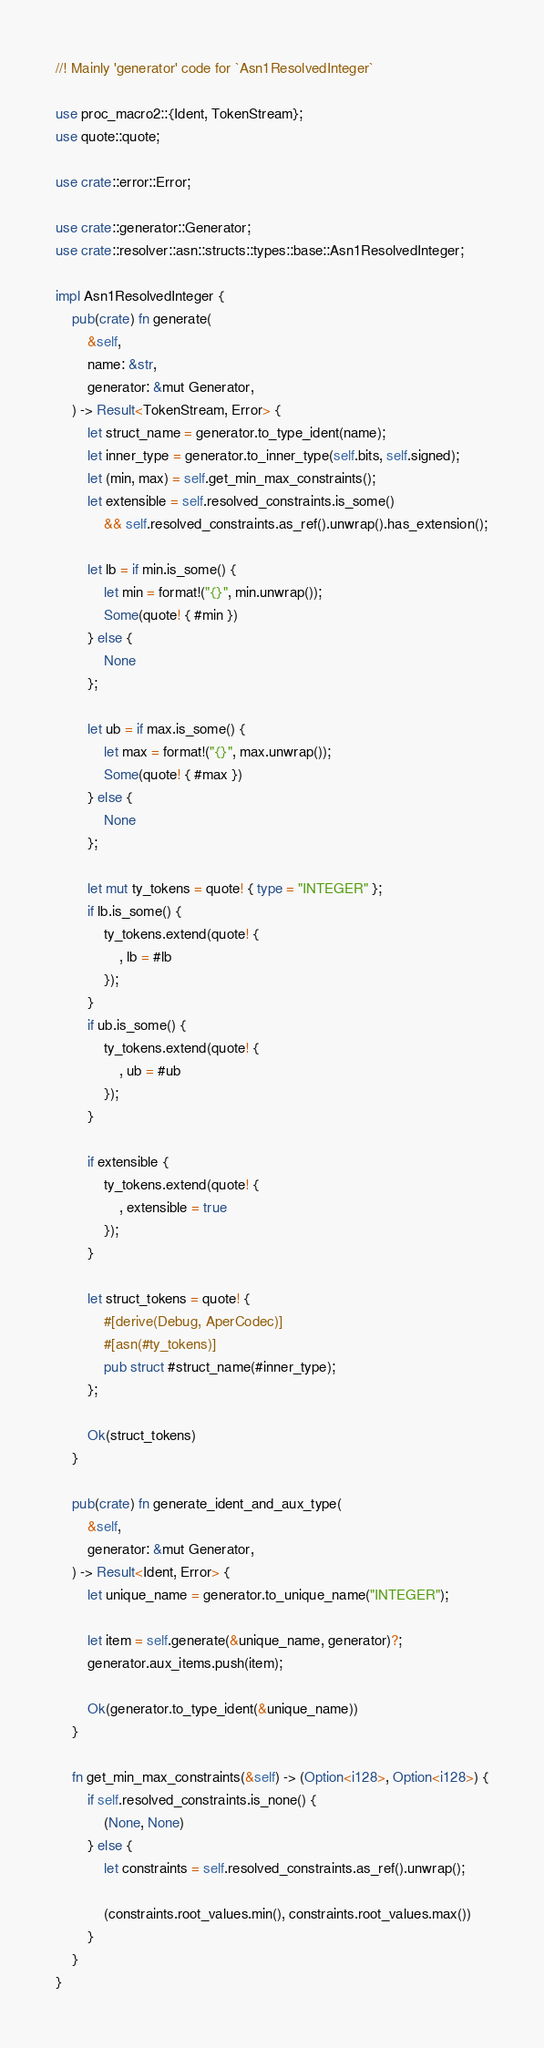<code> <loc_0><loc_0><loc_500><loc_500><_Rust_>//! Mainly 'generator' code for `Asn1ResolvedInteger`

use proc_macro2::{Ident, TokenStream};
use quote::quote;

use crate::error::Error;

use crate::generator::Generator;
use crate::resolver::asn::structs::types::base::Asn1ResolvedInteger;

impl Asn1ResolvedInteger {
    pub(crate) fn generate(
        &self,
        name: &str,
        generator: &mut Generator,
    ) -> Result<TokenStream, Error> {
        let struct_name = generator.to_type_ident(name);
        let inner_type = generator.to_inner_type(self.bits, self.signed);
        let (min, max) = self.get_min_max_constraints();
        let extensible = self.resolved_constraints.is_some()
            && self.resolved_constraints.as_ref().unwrap().has_extension();

        let lb = if min.is_some() {
            let min = format!("{}", min.unwrap());
            Some(quote! { #min })
        } else {
            None
        };

        let ub = if max.is_some() {
            let max = format!("{}", max.unwrap());
            Some(quote! { #max })
        } else {
            None
        };

        let mut ty_tokens = quote! { type = "INTEGER" };
        if lb.is_some() {
            ty_tokens.extend(quote! {
                , lb = #lb
            });
        }
        if ub.is_some() {
            ty_tokens.extend(quote! {
                , ub = #ub
            });
        }

        if extensible {
            ty_tokens.extend(quote! {
                , extensible = true
            });
        }

        let struct_tokens = quote! {
            #[derive(Debug, AperCodec)]
            #[asn(#ty_tokens)]
            pub struct #struct_name(#inner_type);
        };

        Ok(struct_tokens)
    }

    pub(crate) fn generate_ident_and_aux_type(
        &self,
        generator: &mut Generator,
    ) -> Result<Ident, Error> {
        let unique_name = generator.to_unique_name("INTEGER");

        let item = self.generate(&unique_name, generator)?;
        generator.aux_items.push(item);

        Ok(generator.to_type_ident(&unique_name))
    }

    fn get_min_max_constraints(&self) -> (Option<i128>, Option<i128>) {
        if self.resolved_constraints.is_none() {
            (None, None)
        } else {
            let constraints = self.resolved_constraints.as_ref().unwrap();

            (constraints.root_values.min(), constraints.root_values.max())
        }
    }
}
</code> 